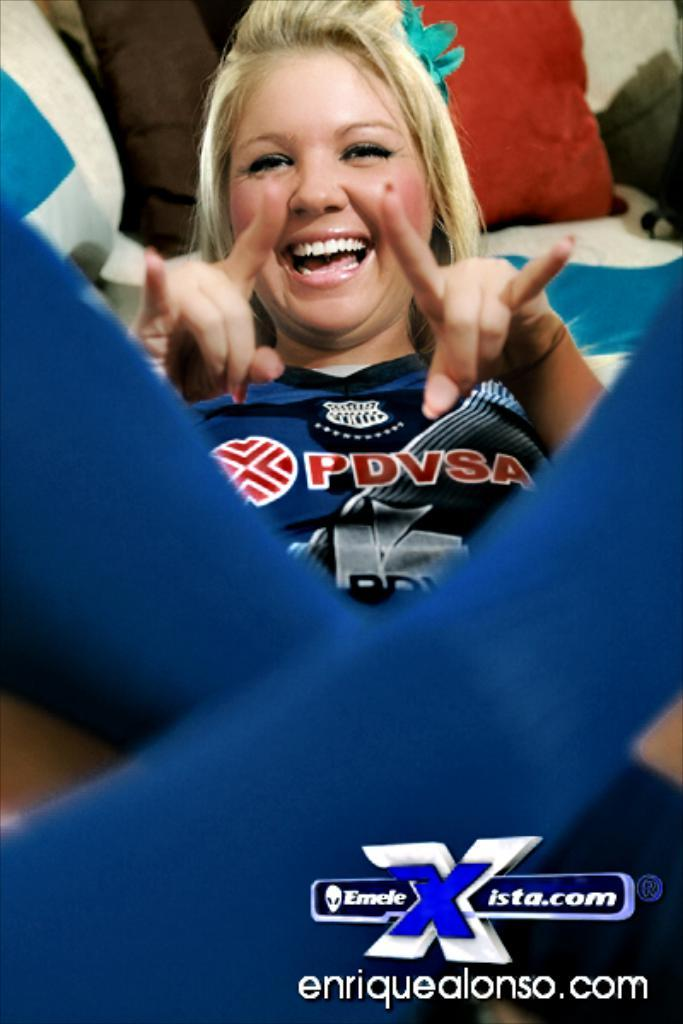Provide a one-sentence caption for the provided image. the photo of the lady wearing PDVSA shirt is by enriquealonso.com. 